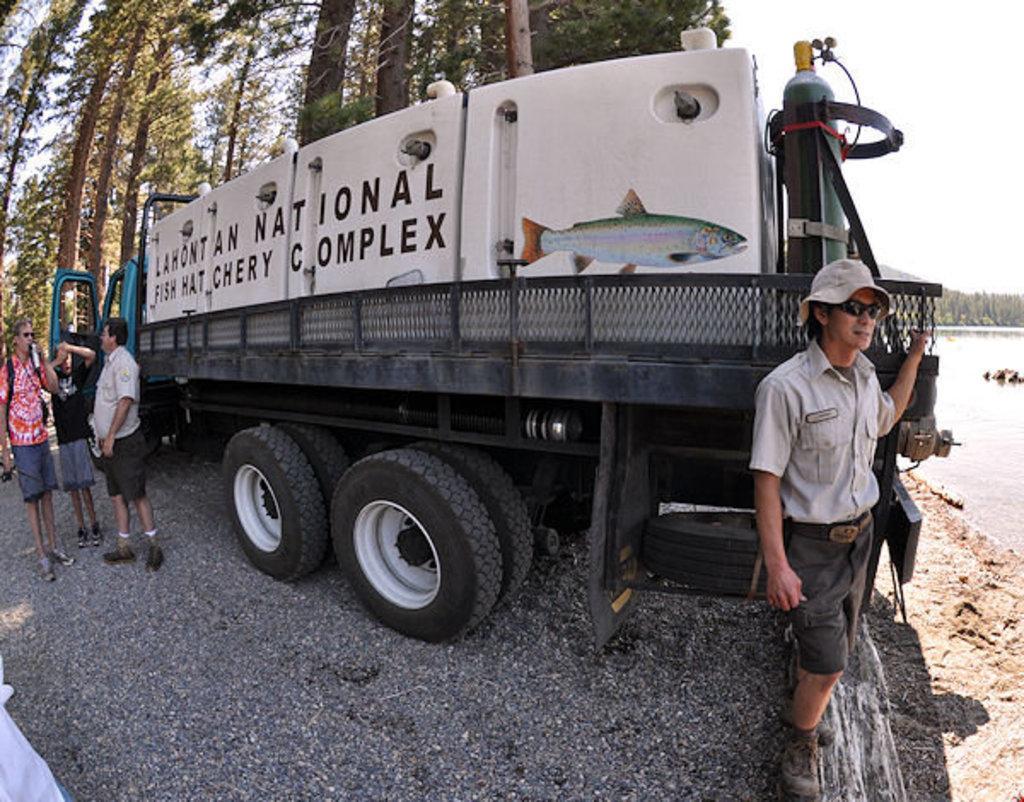In one or two sentences, can you explain what this image depicts? There is a vehicle and there are few persons standing beside it and there is water in the right corner and there are trees in the background. 